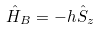Convert formula to latex. <formula><loc_0><loc_0><loc_500><loc_500>\hat { H } _ { B } = - h \hat { S } _ { z }</formula> 